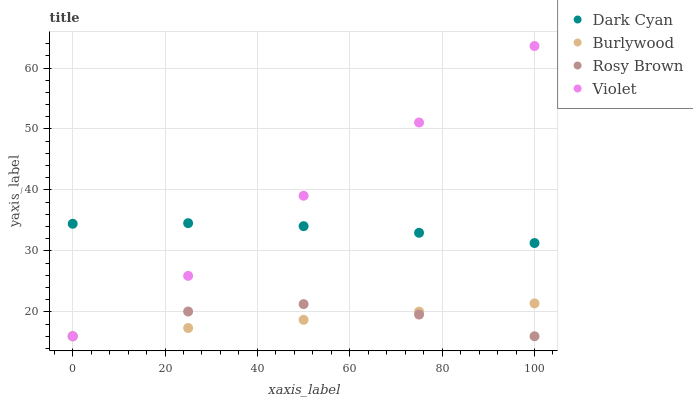Does Burlywood have the minimum area under the curve?
Answer yes or no. Yes. Does Violet have the maximum area under the curve?
Answer yes or no. Yes. Does Rosy Brown have the minimum area under the curve?
Answer yes or no. No. Does Rosy Brown have the maximum area under the curve?
Answer yes or no. No. Is Burlywood the smoothest?
Answer yes or no. Yes. Is Rosy Brown the roughest?
Answer yes or no. Yes. Is Rosy Brown the smoothest?
Answer yes or no. No. Is Burlywood the roughest?
Answer yes or no. No. Does Burlywood have the lowest value?
Answer yes or no. Yes. Does Violet have the highest value?
Answer yes or no. Yes. Does Burlywood have the highest value?
Answer yes or no. No. Is Rosy Brown less than Dark Cyan?
Answer yes or no. Yes. Is Dark Cyan greater than Burlywood?
Answer yes or no. Yes. Does Rosy Brown intersect Burlywood?
Answer yes or no. Yes. Is Rosy Brown less than Burlywood?
Answer yes or no. No. Is Rosy Brown greater than Burlywood?
Answer yes or no. No. Does Rosy Brown intersect Dark Cyan?
Answer yes or no. No. 